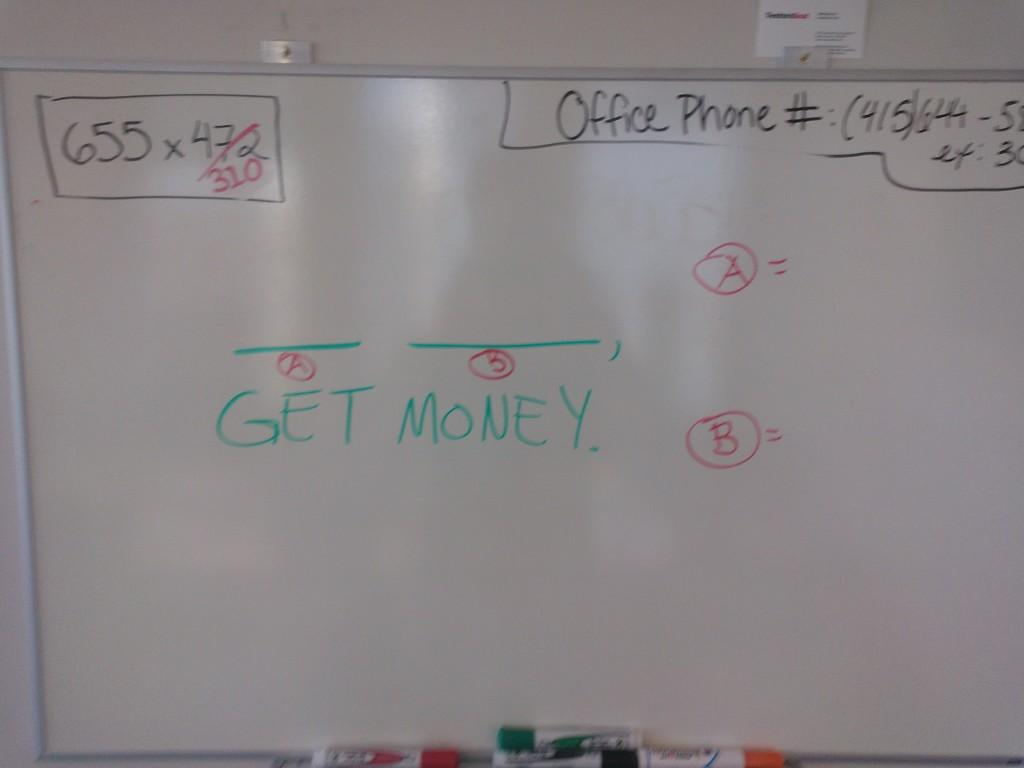<image>
Write a terse but informative summary of the picture. the words get money that are on a board 